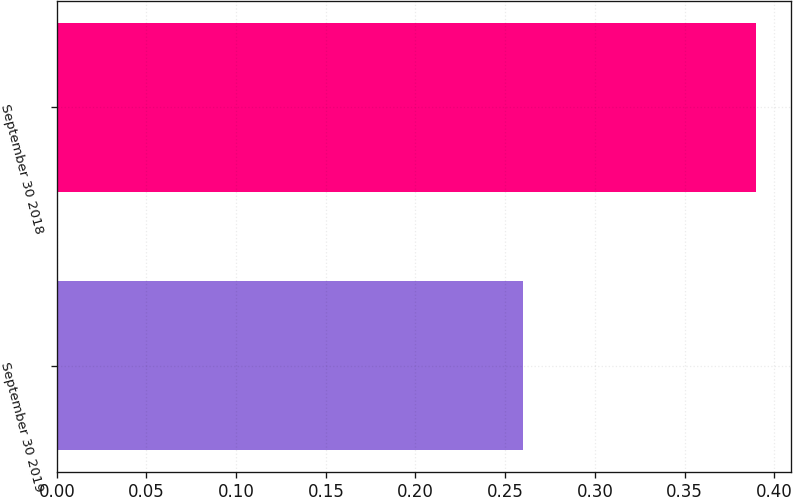Convert chart to OTSL. <chart><loc_0><loc_0><loc_500><loc_500><bar_chart><fcel>September 30 2019<fcel>September 30 2018<nl><fcel>0.26<fcel>0.39<nl></chart> 